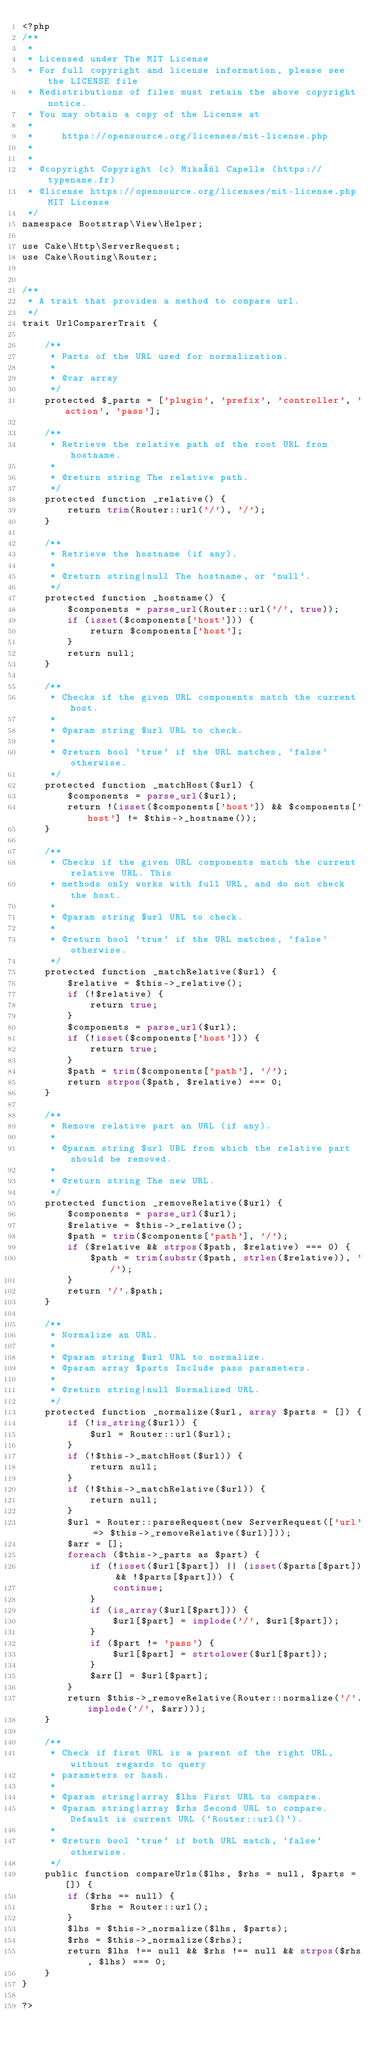<code> <loc_0><loc_0><loc_500><loc_500><_PHP_><?php
/**
 *
 * Licensed under The MIT License
 * For full copyright and license information, please see the LICENSE file
 * Redistributions of files must retain the above copyright notice.
 * You may obtain a copy of the License at
 *
 *     https://opensource.org/licenses/mit-license.php
 *
 *
 * @copyright Copyright (c) Mikaël Capelle (https://typename.fr)
 * @license https://opensource.org/licenses/mit-license.php MIT License
 */
namespace Bootstrap\View\Helper;

use Cake\Http\ServerRequest;
use Cake\Routing\Router;


/**
 * A trait that provides a method to compare url.
 */
trait UrlComparerTrait {

    /**
     * Parts of the URL used for normalization.
     *
     * @var array
     */
    protected $_parts = ['plugin', 'prefix', 'controller', 'action', 'pass'];

    /**
     * Retrieve the relative path of the root URL from hostname.
     *
     * @return string The relative path.
     */
    protected function _relative() {
        return trim(Router::url('/'), '/');
    }

    /**
     * Retrieve the hostname (if any).
     *
     * @return string|null The hostname, or `null`.
     */
    protected function _hostname() {
        $components = parse_url(Router::url('/', true));
        if (isset($components['host'])) {
            return $components['host'];
        }
        return null;
    }

    /**
     * Checks if the given URL components match the current host.
     *
     * @param string $url URL to check.
     *
     * @return bool `true` if the URL matches, `false` otherwise.
     */
    protected function _matchHost($url) {
        $components = parse_url($url);
        return !(isset($components['host']) && $components['host'] != $this->_hostname());
    }

    /**
     * Checks if the given URL components match the current relative URL. This
     * methods only works with full URL, and do not check the host.
     *
     * @param string $url URL to check.
     *
     * @return bool `true` if the URL matches, `false` otherwise.
     */
    protected function _matchRelative($url) {
        $relative = $this->_relative();
        if (!$relative) {
            return true;
        }
        $components = parse_url($url);
        if (!isset($components['host'])) {
            return true;
        }
        $path = trim($components['path'], '/');
        return strpos($path, $relative) === 0;
    }

    /**
     * Remove relative part an URL (if any).
     *
     * @param string $url URL from which the relative part should be removed.
     *
     * @return string The new URL.
     */
    protected function _removeRelative($url) {
        $components = parse_url($url);
        $relative = $this->_relative();
        $path = trim($components['path'], '/');
        if ($relative && strpos($path, $relative) === 0) {
            $path = trim(substr($path, strlen($relative)), '/');
        }
        return '/'.$path;
    }

    /**
     * Normalize an URL.
     *
     * @param string $url URL to normalize.
     * @param array $parts Include pass parameters.
     *
     * @return string|null Normalized URL.
     */
    protected function _normalize($url, array $parts = []) {
        if (!is_string($url)) {
            $url = Router::url($url);
        }
        if (!$this->_matchHost($url)) {
            return null;
        }
        if (!$this->_matchRelative($url)) {
            return null;
        }
        $url = Router::parseRequest(new ServerRequest(['url' => $this->_removeRelative($url)]));
        $arr = [];
        foreach ($this->_parts as $part) {
            if (!isset($url[$part]) || (isset($parts[$part]) && !$parts[$part])) {
                continue;
            }
            if (is_array($url[$part])) {
                $url[$part] = implode('/', $url[$part]);
            }
            if ($part != 'pass') {
                $url[$part] = strtolower($url[$part]);
            }
            $arr[] = $url[$part];
        }
        return $this->_removeRelative(Router::normalize('/'.implode('/', $arr)));
    }

    /**
     * Check if first URL is a parent of the right URL, without regards to query
     * parameters or hash.
     *
     * @param string|array $lhs First URL to compare.
     * @param string|array $rhs Second URL to compare. Default is current URL (`Router::url()`).
     *
     * @return bool `true` if both URL match, `false` otherwise.
     */
    public function compareUrls($lhs, $rhs = null, $parts = []) {
        if ($rhs == null) {
            $rhs = Router::url();
        }
        $lhs = $this->_normalize($lhs, $parts);
        $rhs = $this->_normalize($rhs);
        return $lhs !== null && $rhs !== null && strpos($rhs, $lhs) === 0;
    }
}

?>
</code> 